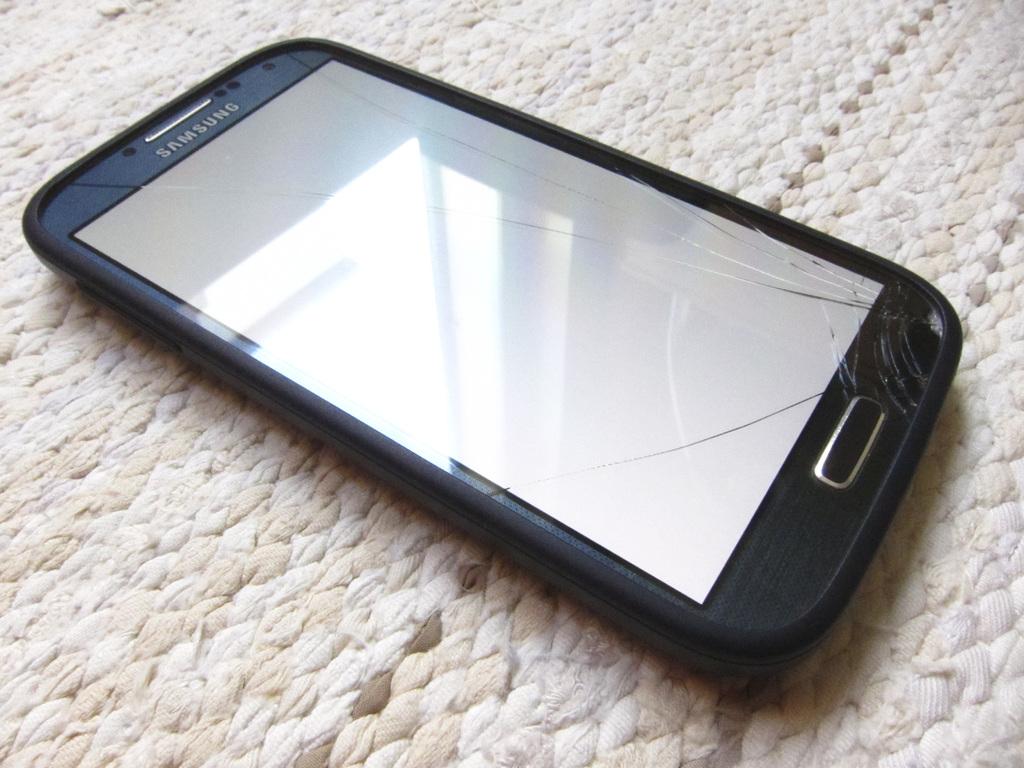What brand cell phone is that?
Keep it short and to the point. Samsung. What brand is the phone?
Provide a short and direct response. Samsung. 